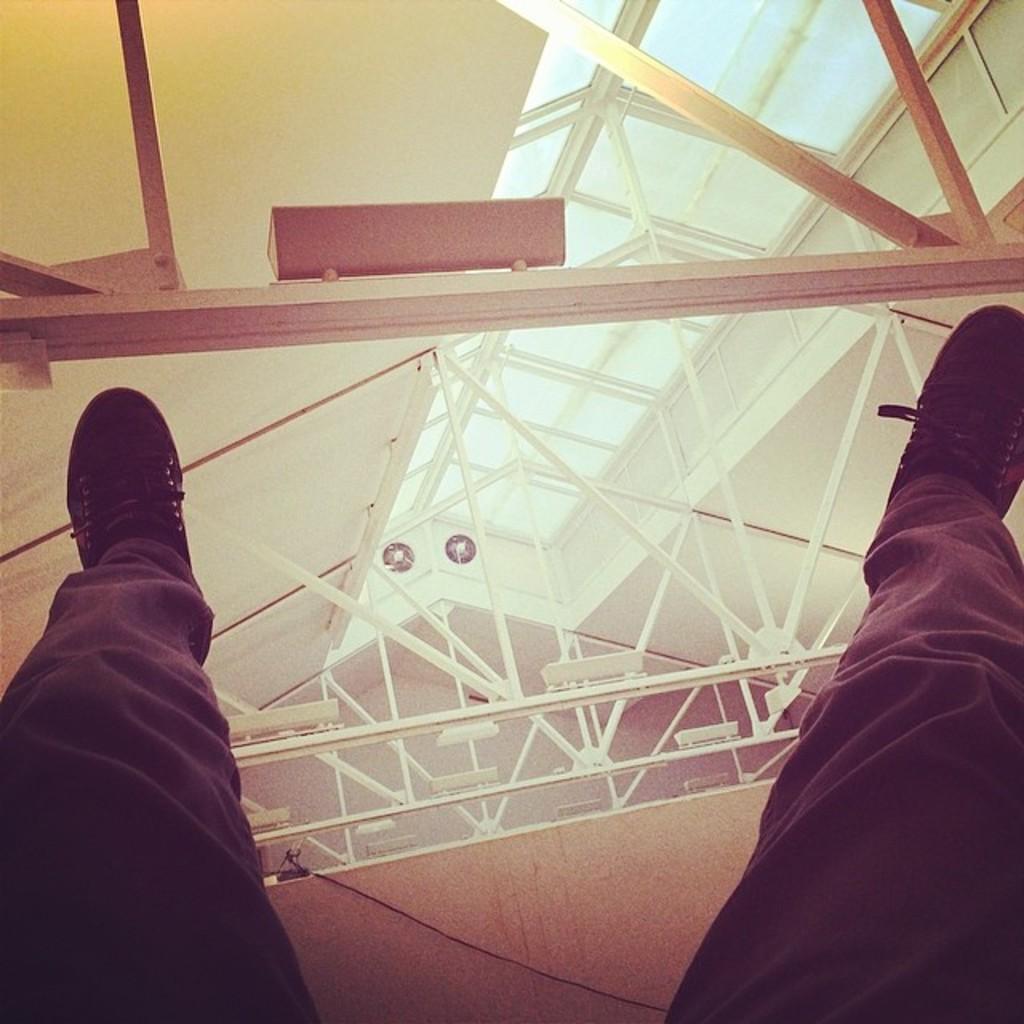How would you summarize this image in a sentence or two? There are legs of a person wearing trouser and shoes. There is roof and 2 exhaust fans are present at the back. 